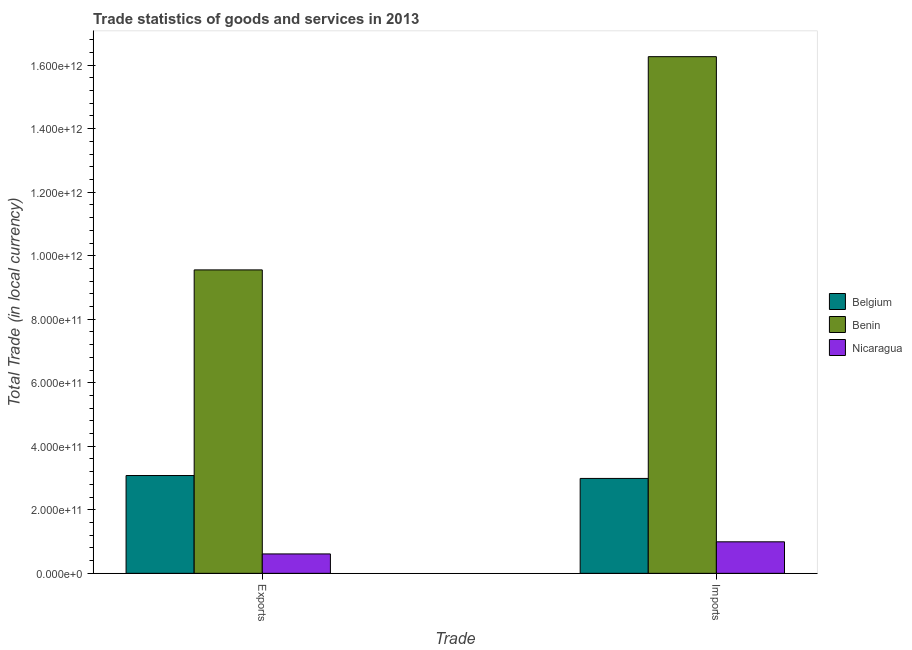Are the number of bars per tick equal to the number of legend labels?
Provide a short and direct response. Yes. How many bars are there on the 2nd tick from the right?
Keep it short and to the point. 3. What is the label of the 2nd group of bars from the left?
Keep it short and to the point. Imports. What is the imports of goods and services in Benin?
Your answer should be very brief. 1.63e+12. Across all countries, what is the maximum imports of goods and services?
Offer a terse response. 1.63e+12. Across all countries, what is the minimum imports of goods and services?
Give a very brief answer. 9.92e+1. In which country was the imports of goods and services maximum?
Offer a terse response. Benin. In which country was the imports of goods and services minimum?
Give a very brief answer. Nicaragua. What is the total imports of goods and services in the graph?
Give a very brief answer. 2.02e+12. What is the difference between the export of goods and services in Benin and that in Nicaragua?
Your answer should be compact. 8.94e+11. What is the difference between the export of goods and services in Benin and the imports of goods and services in Belgium?
Your answer should be compact. 6.57e+11. What is the average export of goods and services per country?
Make the answer very short. 4.41e+11. What is the difference between the imports of goods and services and export of goods and services in Nicaragua?
Make the answer very short. 3.81e+1. What is the ratio of the imports of goods and services in Nicaragua to that in Benin?
Give a very brief answer. 0.06. What does the 2nd bar from the left in Imports represents?
Ensure brevity in your answer.  Benin. What does the 2nd bar from the right in Exports represents?
Your answer should be compact. Benin. Are all the bars in the graph horizontal?
Provide a short and direct response. No. What is the difference between two consecutive major ticks on the Y-axis?
Make the answer very short. 2.00e+11. Are the values on the major ticks of Y-axis written in scientific E-notation?
Your answer should be very brief. Yes. Does the graph contain any zero values?
Ensure brevity in your answer.  No. What is the title of the graph?
Ensure brevity in your answer.  Trade statistics of goods and services in 2013. Does "Morocco" appear as one of the legend labels in the graph?
Give a very brief answer. No. What is the label or title of the X-axis?
Provide a short and direct response. Trade. What is the label or title of the Y-axis?
Make the answer very short. Total Trade (in local currency). What is the Total Trade (in local currency) of Belgium in Exports?
Offer a terse response. 3.08e+11. What is the Total Trade (in local currency) of Benin in Exports?
Offer a very short reply. 9.55e+11. What is the Total Trade (in local currency) of Nicaragua in Exports?
Give a very brief answer. 6.11e+1. What is the Total Trade (in local currency) of Belgium in Imports?
Make the answer very short. 2.99e+11. What is the Total Trade (in local currency) of Benin in Imports?
Provide a short and direct response. 1.63e+12. What is the Total Trade (in local currency) in Nicaragua in Imports?
Offer a very short reply. 9.92e+1. Across all Trade, what is the maximum Total Trade (in local currency) of Belgium?
Your response must be concise. 3.08e+11. Across all Trade, what is the maximum Total Trade (in local currency) of Benin?
Your answer should be compact. 1.63e+12. Across all Trade, what is the maximum Total Trade (in local currency) of Nicaragua?
Give a very brief answer. 9.92e+1. Across all Trade, what is the minimum Total Trade (in local currency) in Belgium?
Give a very brief answer. 2.99e+11. Across all Trade, what is the minimum Total Trade (in local currency) in Benin?
Ensure brevity in your answer.  9.55e+11. Across all Trade, what is the minimum Total Trade (in local currency) of Nicaragua?
Keep it short and to the point. 6.11e+1. What is the total Total Trade (in local currency) in Belgium in the graph?
Ensure brevity in your answer.  6.07e+11. What is the total Total Trade (in local currency) of Benin in the graph?
Give a very brief answer. 2.58e+12. What is the total Total Trade (in local currency) in Nicaragua in the graph?
Ensure brevity in your answer.  1.60e+11. What is the difference between the Total Trade (in local currency) in Belgium in Exports and that in Imports?
Make the answer very short. 9.16e+09. What is the difference between the Total Trade (in local currency) of Benin in Exports and that in Imports?
Your response must be concise. -6.71e+11. What is the difference between the Total Trade (in local currency) in Nicaragua in Exports and that in Imports?
Offer a terse response. -3.81e+1. What is the difference between the Total Trade (in local currency) in Belgium in Exports and the Total Trade (in local currency) in Benin in Imports?
Give a very brief answer. -1.32e+12. What is the difference between the Total Trade (in local currency) in Belgium in Exports and the Total Trade (in local currency) in Nicaragua in Imports?
Your answer should be very brief. 2.09e+11. What is the difference between the Total Trade (in local currency) of Benin in Exports and the Total Trade (in local currency) of Nicaragua in Imports?
Give a very brief answer. 8.56e+11. What is the average Total Trade (in local currency) in Belgium per Trade?
Your response must be concise. 3.03e+11. What is the average Total Trade (in local currency) of Benin per Trade?
Keep it short and to the point. 1.29e+12. What is the average Total Trade (in local currency) of Nicaragua per Trade?
Ensure brevity in your answer.  8.02e+1. What is the difference between the Total Trade (in local currency) in Belgium and Total Trade (in local currency) in Benin in Exports?
Your answer should be very brief. -6.47e+11. What is the difference between the Total Trade (in local currency) in Belgium and Total Trade (in local currency) in Nicaragua in Exports?
Provide a short and direct response. 2.47e+11. What is the difference between the Total Trade (in local currency) in Benin and Total Trade (in local currency) in Nicaragua in Exports?
Give a very brief answer. 8.94e+11. What is the difference between the Total Trade (in local currency) in Belgium and Total Trade (in local currency) in Benin in Imports?
Your answer should be very brief. -1.33e+12. What is the difference between the Total Trade (in local currency) of Belgium and Total Trade (in local currency) of Nicaragua in Imports?
Offer a very short reply. 2.00e+11. What is the difference between the Total Trade (in local currency) in Benin and Total Trade (in local currency) in Nicaragua in Imports?
Provide a short and direct response. 1.53e+12. What is the ratio of the Total Trade (in local currency) of Belgium in Exports to that in Imports?
Keep it short and to the point. 1.03. What is the ratio of the Total Trade (in local currency) of Benin in Exports to that in Imports?
Provide a succinct answer. 0.59. What is the ratio of the Total Trade (in local currency) of Nicaragua in Exports to that in Imports?
Ensure brevity in your answer.  0.62. What is the difference between the highest and the second highest Total Trade (in local currency) of Belgium?
Make the answer very short. 9.16e+09. What is the difference between the highest and the second highest Total Trade (in local currency) in Benin?
Your answer should be very brief. 6.71e+11. What is the difference between the highest and the second highest Total Trade (in local currency) in Nicaragua?
Your response must be concise. 3.81e+1. What is the difference between the highest and the lowest Total Trade (in local currency) of Belgium?
Keep it short and to the point. 9.16e+09. What is the difference between the highest and the lowest Total Trade (in local currency) in Benin?
Give a very brief answer. 6.71e+11. What is the difference between the highest and the lowest Total Trade (in local currency) in Nicaragua?
Offer a very short reply. 3.81e+1. 